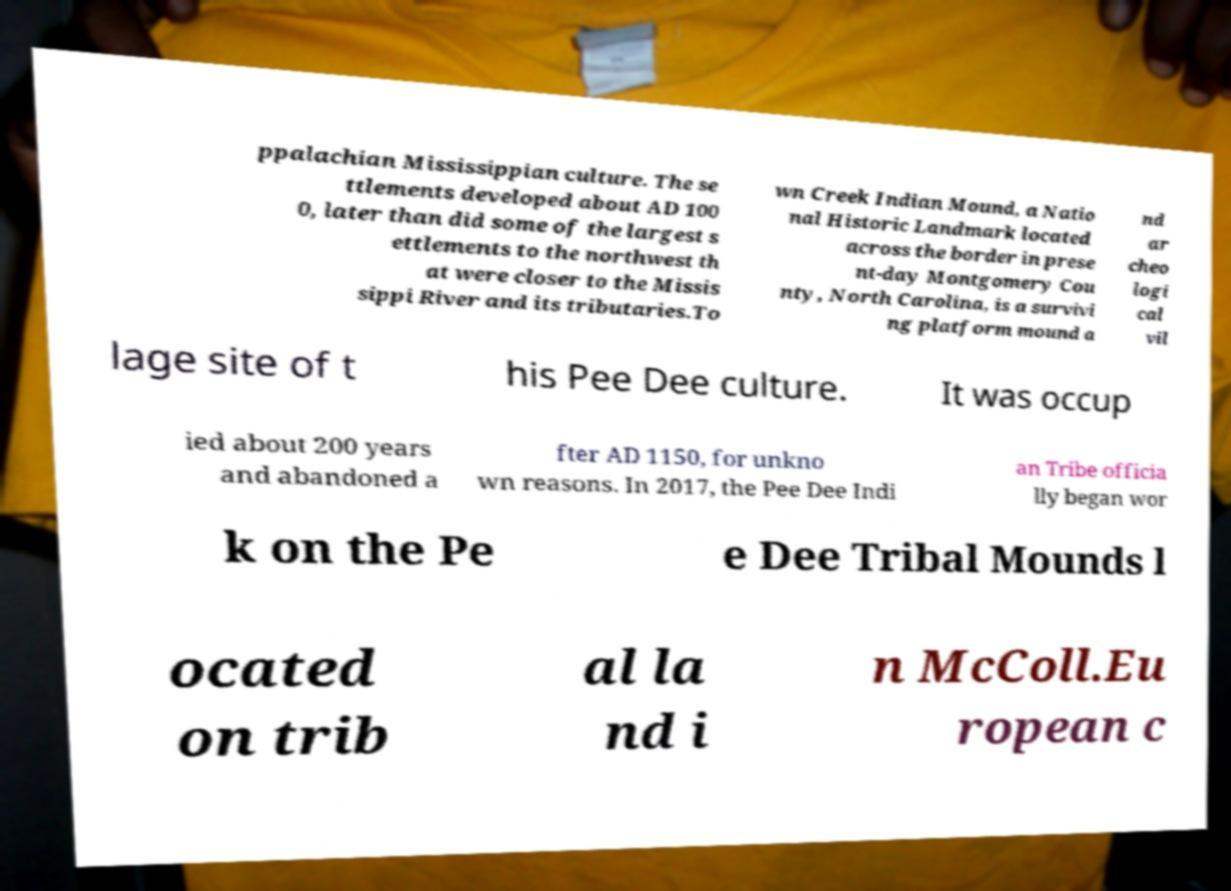I need the written content from this picture converted into text. Can you do that? ppalachian Mississippian culture. The se ttlements developed about AD 100 0, later than did some of the largest s ettlements to the northwest th at were closer to the Missis sippi River and its tributaries.To wn Creek Indian Mound, a Natio nal Historic Landmark located across the border in prese nt-day Montgomery Cou nty, North Carolina, is a survivi ng platform mound a nd ar cheo logi cal vil lage site of t his Pee Dee culture. It was occup ied about 200 years and abandoned a fter AD 1150, for unkno wn reasons. In 2017, the Pee Dee Indi an Tribe officia lly began wor k on the Pe e Dee Tribal Mounds l ocated on trib al la nd i n McColl.Eu ropean c 